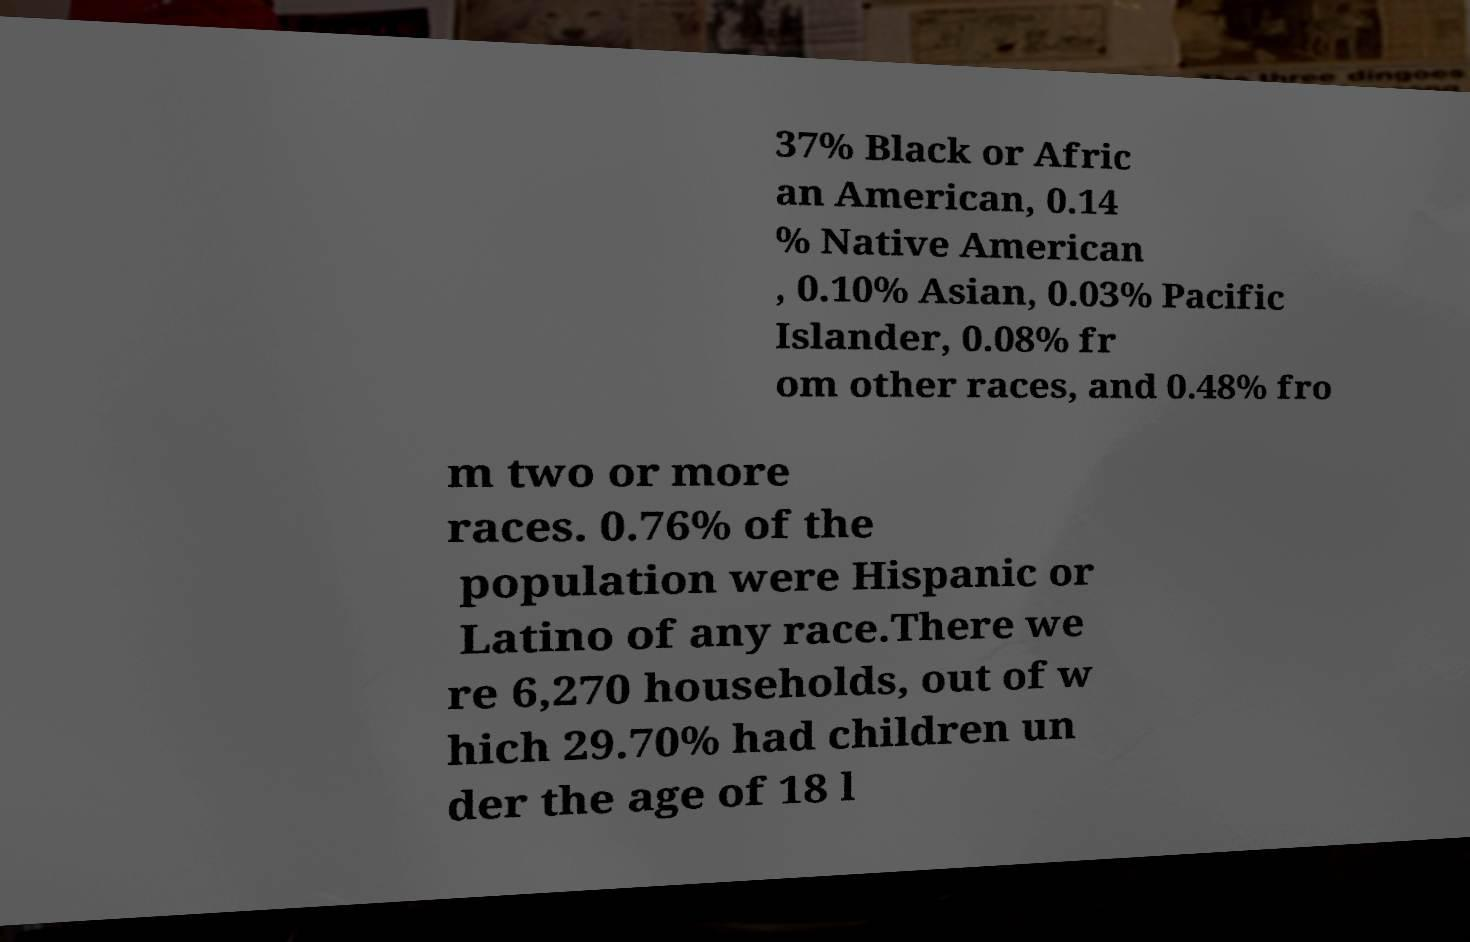What messages or text are displayed in this image? I need them in a readable, typed format. 37% Black or Afric an American, 0.14 % Native American , 0.10% Asian, 0.03% Pacific Islander, 0.08% fr om other races, and 0.48% fro m two or more races. 0.76% of the population were Hispanic or Latino of any race.There we re 6,270 households, out of w hich 29.70% had children un der the age of 18 l 